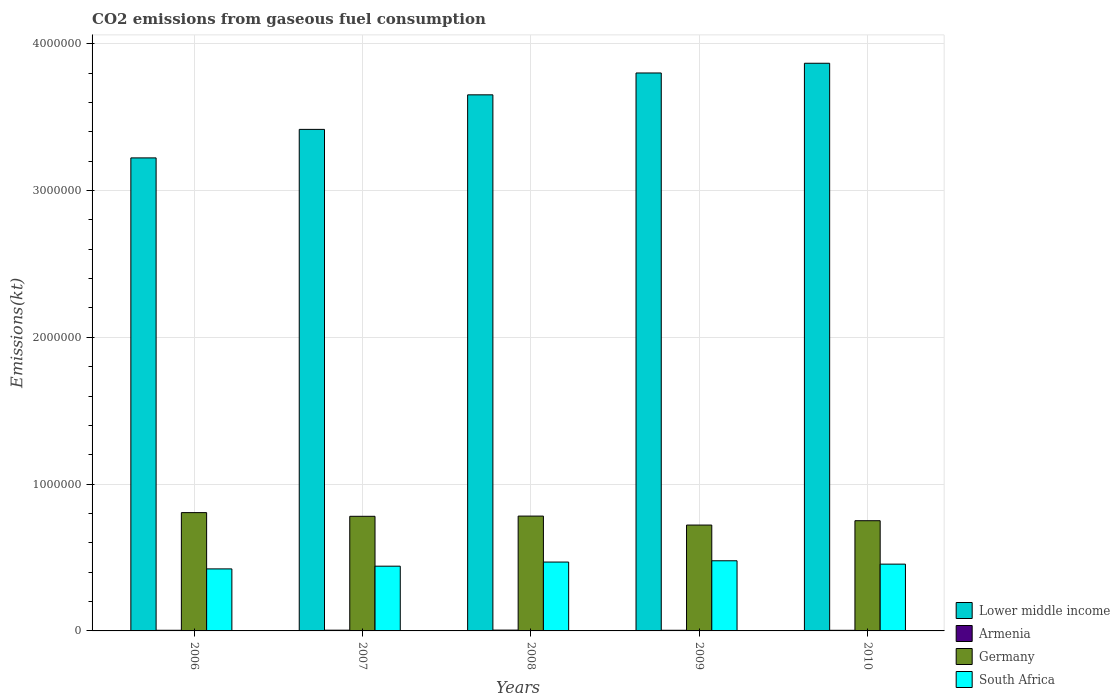How many bars are there on the 1st tick from the left?
Provide a succinct answer. 4. How many bars are there on the 4th tick from the right?
Offer a terse response. 4. What is the amount of CO2 emitted in South Africa in 2010?
Provide a succinct answer. 4.55e+05. Across all years, what is the maximum amount of CO2 emitted in South Africa?
Provide a succinct answer. 4.78e+05. Across all years, what is the minimum amount of CO2 emitted in Germany?
Offer a very short reply. 7.21e+05. In which year was the amount of CO2 emitted in Germany maximum?
Offer a very short reply. 2006. In which year was the amount of CO2 emitted in Lower middle income minimum?
Your response must be concise. 2006. What is the total amount of CO2 emitted in Germany in the graph?
Give a very brief answer. 3.84e+06. What is the difference between the amount of CO2 emitted in Germany in 2008 and that in 2009?
Provide a short and direct response. 6.11e+04. What is the difference between the amount of CO2 emitted in Lower middle income in 2008 and the amount of CO2 emitted in Germany in 2007?
Make the answer very short. 2.87e+06. What is the average amount of CO2 emitted in Lower middle income per year?
Your answer should be compact. 3.59e+06. In the year 2010, what is the difference between the amount of CO2 emitted in Germany and amount of CO2 emitted in Lower middle income?
Your answer should be very brief. -3.12e+06. What is the ratio of the amount of CO2 emitted in Armenia in 2008 to that in 2010?
Your answer should be compact. 1.32. Is the difference between the amount of CO2 emitted in Germany in 2007 and 2009 greater than the difference between the amount of CO2 emitted in Lower middle income in 2007 and 2009?
Your response must be concise. Yes. What is the difference between the highest and the second highest amount of CO2 emitted in Lower middle income?
Your answer should be compact. 6.62e+04. What is the difference between the highest and the lowest amount of CO2 emitted in South Africa?
Offer a very short reply. 5.54e+04. Is it the case that in every year, the sum of the amount of CO2 emitted in Lower middle income and amount of CO2 emitted in Germany is greater than the sum of amount of CO2 emitted in Armenia and amount of CO2 emitted in South Africa?
Your answer should be very brief. No. Is it the case that in every year, the sum of the amount of CO2 emitted in Armenia and amount of CO2 emitted in Lower middle income is greater than the amount of CO2 emitted in Germany?
Provide a succinct answer. Yes. How many bars are there?
Offer a terse response. 20. Are all the bars in the graph horizontal?
Ensure brevity in your answer.  No. What is the difference between two consecutive major ticks on the Y-axis?
Offer a very short reply. 1.00e+06. Are the values on the major ticks of Y-axis written in scientific E-notation?
Offer a very short reply. No. Does the graph contain any zero values?
Provide a succinct answer. No. Where does the legend appear in the graph?
Offer a very short reply. Bottom right. How many legend labels are there?
Your response must be concise. 4. How are the legend labels stacked?
Provide a succinct answer. Vertical. What is the title of the graph?
Your answer should be compact. CO2 emissions from gaseous fuel consumption. Does "Pacific island small states" appear as one of the legend labels in the graph?
Offer a terse response. No. What is the label or title of the X-axis?
Ensure brevity in your answer.  Years. What is the label or title of the Y-axis?
Offer a very short reply. Emissions(kt). What is the Emissions(kt) in Lower middle income in 2006?
Ensure brevity in your answer.  3.22e+06. What is the Emissions(kt) of Armenia in 2006?
Your answer should be compact. 4382.06. What is the Emissions(kt) of Germany in 2006?
Provide a short and direct response. 8.06e+05. What is the Emissions(kt) of South Africa in 2006?
Your answer should be very brief. 4.22e+05. What is the Emissions(kt) of Lower middle income in 2007?
Your answer should be compact. 3.42e+06. What is the Emissions(kt) of Armenia in 2007?
Your response must be concise. 5064.13. What is the Emissions(kt) in Germany in 2007?
Your response must be concise. 7.81e+05. What is the Emissions(kt) of South Africa in 2007?
Offer a very short reply. 4.41e+05. What is the Emissions(kt) in Lower middle income in 2008?
Offer a terse response. 3.65e+06. What is the Emissions(kt) in Armenia in 2008?
Offer a terse response. 5559.17. What is the Emissions(kt) in Germany in 2008?
Offer a terse response. 7.82e+05. What is the Emissions(kt) in South Africa in 2008?
Offer a terse response. 4.69e+05. What is the Emissions(kt) in Lower middle income in 2009?
Your answer should be compact. 3.80e+06. What is the Emissions(kt) in Armenia in 2009?
Provide a succinct answer. 4360.06. What is the Emissions(kt) of Germany in 2009?
Make the answer very short. 7.21e+05. What is the Emissions(kt) in South Africa in 2009?
Your response must be concise. 4.78e+05. What is the Emissions(kt) of Lower middle income in 2010?
Provide a short and direct response. 3.87e+06. What is the Emissions(kt) in Armenia in 2010?
Ensure brevity in your answer.  4217.05. What is the Emissions(kt) in Germany in 2010?
Your answer should be very brief. 7.51e+05. What is the Emissions(kt) in South Africa in 2010?
Provide a short and direct response. 4.55e+05. Across all years, what is the maximum Emissions(kt) of Lower middle income?
Provide a short and direct response. 3.87e+06. Across all years, what is the maximum Emissions(kt) in Armenia?
Keep it short and to the point. 5559.17. Across all years, what is the maximum Emissions(kt) of Germany?
Provide a succinct answer. 8.06e+05. Across all years, what is the maximum Emissions(kt) in South Africa?
Your answer should be compact. 4.78e+05. Across all years, what is the minimum Emissions(kt) in Lower middle income?
Provide a short and direct response. 3.22e+06. Across all years, what is the minimum Emissions(kt) of Armenia?
Offer a terse response. 4217.05. Across all years, what is the minimum Emissions(kt) in Germany?
Provide a succinct answer. 7.21e+05. Across all years, what is the minimum Emissions(kt) of South Africa?
Your answer should be compact. 4.22e+05. What is the total Emissions(kt) in Lower middle income in the graph?
Offer a terse response. 1.80e+07. What is the total Emissions(kt) of Armenia in the graph?
Make the answer very short. 2.36e+04. What is the total Emissions(kt) in Germany in the graph?
Your answer should be compact. 3.84e+06. What is the total Emissions(kt) of South Africa in the graph?
Keep it short and to the point. 2.27e+06. What is the difference between the Emissions(kt) in Lower middle income in 2006 and that in 2007?
Your answer should be compact. -1.94e+05. What is the difference between the Emissions(kt) of Armenia in 2006 and that in 2007?
Provide a succinct answer. -682.06. What is the difference between the Emissions(kt) in Germany in 2006 and that in 2007?
Keep it short and to the point. 2.52e+04. What is the difference between the Emissions(kt) in South Africa in 2006 and that in 2007?
Keep it short and to the point. -1.85e+04. What is the difference between the Emissions(kt) in Lower middle income in 2006 and that in 2008?
Make the answer very short. -4.30e+05. What is the difference between the Emissions(kt) in Armenia in 2006 and that in 2008?
Offer a terse response. -1177.11. What is the difference between the Emissions(kt) in Germany in 2006 and that in 2008?
Provide a short and direct response. 2.37e+04. What is the difference between the Emissions(kt) in South Africa in 2006 and that in 2008?
Give a very brief answer. -4.66e+04. What is the difference between the Emissions(kt) in Lower middle income in 2006 and that in 2009?
Make the answer very short. -5.78e+05. What is the difference between the Emissions(kt) in Armenia in 2006 and that in 2009?
Keep it short and to the point. 22. What is the difference between the Emissions(kt) of Germany in 2006 and that in 2009?
Offer a terse response. 8.48e+04. What is the difference between the Emissions(kt) in South Africa in 2006 and that in 2009?
Give a very brief answer. -5.54e+04. What is the difference between the Emissions(kt) of Lower middle income in 2006 and that in 2010?
Provide a succinct answer. -6.45e+05. What is the difference between the Emissions(kt) of Armenia in 2006 and that in 2010?
Ensure brevity in your answer.  165.01. What is the difference between the Emissions(kt) of Germany in 2006 and that in 2010?
Provide a succinct answer. 5.51e+04. What is the difference between the Emissions(kt) of South Africa in 2006 and that in 2010?
Keep it short and to the point. -3.25e+04. What is the difference between the Emissions(kt) of Lower middle income in 2007 and that in 2008?
Keep it short and to the point. -2.35e+05. What is the difference between the Emissions(kt) in Armenia in 2007 and that in 2008?
Ensure brevity in your answer.  -495.05. What is the difference between the Emissions(kt) of Germany in 2007 and that in 2008?
Make the answer very short. -1525.47. What is the difference between the Emissions(kt) in South Africa in 2007 and that in 2008?
Make the answer very short. -2.81e+04. What is the difference between the Emissions(kt) in Lower middle income in 2007 and that in 2009?
Ensure brevity in your answer.  -3.84e+05. What is the difference between the Emissions(kt) in Armenia in 2007 and that in 2009?
Your response must be concise. 704.06. What is the difference between the Emissions(kt) in Germany in 2007 and that in 2009?
Keep it short and to the point. 5.96e+04. What is the difference between the Emissions(kt) of South Africa in 2007 and that in 2009?
Offer a very short reply. -3.68e+04. What is the difference between the Emissions(kt) in Lower middle income in 2007 and that in 2010?
Keep it short and to the point. -4.50e+05. What is the difference between the Emissions(kt) in Armenia in 2007 and that in 2010?
Give a very brief answer. 847.08. What is the difference between the Emissions(kt) of Germany in 2007 and that in 2010?
Ensure brevity in your answer.  2.99e+04. What is the difference between the Emissions(kt) in South Africa in 2007 and that in 2010?
Make the answer very short. -1.40e+04. What is the difference between the Emissions(kt) of Lower middle income in 2008 and that in 2009?
Give a very brief answer. -1.49e+05. What is the difference between the Emissions(kt) in Armenia in 2008 and that in 2009?
Provide a short and direct response. 1199.11. What is the difference between the Emissions(kt) of Germany in 2008 and that in 2009?
Your answer should be compact. 6.11e+04. What is the difference between the Emissions(kt) in South Africa in 2008 and that in 2009?
Keep it short and to the point. -8716.46. What is the difference between the Emissions(kt) in Lower middle income in 2008 and that in 2010?
Offer a very short reply. -2.15e+05. What is the difference between the Emissions(kt) of Armenia in 2008 and that in 2010?
Offer a terse response. 1342.12. What is the difference between the Emissions(kt) in Germany in 2008 and that in 2010?
Ensure brevity in your answer.  3.15e+04. What is the difference between the Emissions(kt) in South Africa in 2008 and that in 2010?
Give a very brief answer. 1.41e+04. What is the difference between the Emissions(kt) of Lower middle income in 2009 and that in 2010?
Offer a terse response. -6.62e+04. What is the difference between the Emissions(kt) of Armenia in 2009 and that in 2010?
Offer a very short reply. 143.01. What is the difference between the Emissions(kt) of Germany in 2009 and that in 2010?
Give a very brief answer. -2.96e+04. What is the difference between the Emissions(kt) in South Africa in 2009 and that in 2010?
Ensure brevity in your answer.  2.29e+04. What is the difference between the Emissions(kt) in Lower middle income in 2006 and the Emissions(kt) in Armenia in 2007?
Your answer should be very brief. 3.22e+06. What is the difference between the Emissions(kt) in Lower middle income in 2006 and the Emissions(kt) in Germany in 2007?
Your answer should be compact. 2.44e+06. What is the difference between the Emissions(kt) of Lower middle income in 2006 and the Emissions(kt) of South Africa in 2007?
Ensure brevity in your answer.  2.78e+06. What is the difference between the Emissions(kt) in Armenia in 2006 and the Emissions(kt) in Germany in 2007?
Your answer should be very brief. -7.76e+05. What is the difference between the Emissions(kt) in Armenia in 2006 and the Emissions(kt) in South Africa in 2007?
Your response must be concise. -4.37e+05. What is the difference between the Emissions(kt) of Germany in 2006 and the Emissions(kt) of South Africa in 2007?
Offer a very short reply. 3.65e+05. What is the difference between the Emissions(kt) of Lower middle income in 2006 and the Emissions(kt) of Armenia in 2008?
Ensure brevity in your answer.  3.22e+06. What is the difference between the Emissions(kt) in Lower middle income in 2006 and the Emissions(kt) in Germany in 2008?
Make the answer very short. 2.44e+06. What is the difference between the Emissions(kt) of Lower middle income in 2006 and the Emissions(kt) of South Africa in 2008?
Your answer should be compact. 2.75e+06. What is the difference between the Emissions(kt) in Armenia in 2006 and the Emissions(kt) in Germany in 2008?
Your response must be concise. -7.78e+05. What is the difference between the Emissions(kt) in Armenia in 2006 and the Emissions(kt) in South Africa in 2008?
Provide a succinct answer. -4.65e+05. What is the difference between the Emissions(kt) in Germany in 2006 and the Emissions(kt) in South Africa in 2008?
Make the answer very short. 3.37e+05. What is the difference between the Emissions(kt) of Lower middle income in 2006 and the Emissions(kt) of Armenia in 2009?
Your answer should be very brief. 3.22e+06. What is the difference between the Emissions(kt) of Lower middle income in 2006 and the Emissions(kt) of Germany in 2009?
Make the answer very short. 2.50e+06. What is the difference between the Emissions(kt) of Lower middle income in 2006 and the Emissions(kt) of South Africa in 2009?
Your answer should be very brief. 2.74e+06. What is the difference between the Emissions(kt) of Armenia in 2006 and the Emissions(kt) of Germany in 2009?
Provide a succinct answer. -7.17e+05. What is the difference between the Emissions(kt) of Armenia in 2006 and the Emissions(kt) of South Africa in 2009?
Provide a short and direct response. -4.73e+05. What is the difference between the Emissions(kt) in Germany in 2006 and the Emissions(kt) in South Africa in 2009?
Provide a succinct answer. 3.28e+05. What is the difference between the Emissions(kt) of Lower middle income in 2006 and the Emissions(kt) of Armenia in 2010?
Provide a succinct answer. 3.22e+06. What is the difference between the Emissions(kt) in Lower middle income in 2006 and the Emissions(kt) in Germany in 2010?
Provide a short and direct response. 2.47e+06. What is the difference between the Emissions(kt) in Lower middle income in 2006 and the Emissions(kt) in South Africa in 2010?
Your response must be concise. 2.77e+06. What is the difference between the Emissions(kt) in Armenia in 2006 and the Emissions(kt) in Germany in 2010?
Offer a terse response. -7.46e+05. What is the difference between the Emissions(kt) of Armenia in 2006 and the Emissions(kt) of South Africa in 2010?
Your response must be concise. -4.51e+05. What is the difference between the Emissions(kt) in Germany in 2006 and the Emissions(kt) in South Africa in 2010?
Offer a terse response. 3.51e+05. What is the difference between the Emissions(kt) of Lower middle income in 2007 and the Emissions(kt) of Armenia in 2008?
Your answer should be compact. 3.41e+06. What is the difference between the Emissions(kt) of Lower middle income in 2007 and the Emissions(kt) of Germany in 2008?
Give a very brief answer. 2.63e+06. What is the difference between the Emissions(kt) in Lower middle income in 2007 and the Emissions(kt) in South Africa in 2008?
Your answer should be compact. 2.95e+06. What is the difference between the Emissions(kt) of Armenia in 2007 and the Emissions(kt) of Germany in 2008?
Offer a terse response. -7.77e+05. What is the difference between the Emissions(kt) of Armenia in 2007 and the Emissions(kt) of South Africa in 2008?
Give a very brief answer. -4.64e+05. What is the difference between the Emissions(kt) in Germany in 2007 and the Emissions(kt) in South Africa in 2008?
Offer a terse response. 3.12e+05. What is the difference between the Emissions(kt) in Lower middle income in 2007 and the Emissions(kt) in Armenia in 2009?
Provide a succinct answer. 3.41e+06. What is the difference between the Emissions(kt) of Lower middle income in 2007 and the Emissions(kt) of Germany in 2009?
Ensure brevity in your answer.  2.70e+06. What is the difference between the Emissions(kt) of Lower middle income in 2007 and the Emissions(kt) of South Africa in 2009?
Your response must be concise. 2.94e+06. What is the difference between the Emissions(kt) of Armenia in 2007 and the Emissions(kt) of Germany in 2009?
Offer a very short reply. -7.16e+05. What is the difference between the Emissions(kt) of Armenia in 2007 and the Emissions(kt) of South Africa in 2009?
Offer a terse response. -4.73e+05. What is the difference between the Emissions(kt) in Germany in 2007 and the Emissions(kt) in South Africa in 2009?
Provide a succinct answer. 3.03e+05. What is the difference between the Emissions(kt) of Lower middle income in 2007 and the Emissions(kt) of Armenia in 2010?
Offer a terse response. 3.41e+06. What is the difference between the Emissions(kt) in Lower middle income in 2007 and the Emissions(kt) in Germany in 2010?
Keep it short and to the point. 2.67e+06. What is the difference between the Emissions(kt) of Lower middle income in 2007 and the Emissions(kt) of South Africa in 2010?
Give a very brief answer. 2.96e+06. What is the difference between the Emissions(kt) of Armenia in 2007 and the Emissions(kt) of Germany in 2010?
Provide a short and direct response. -7.46e+05. What is the difference between the Emissions(kt) of Armenia in 2007 and the Emissions(kt) of South Africa in 2010?
Provide a succinct answer. -4.50e+05. What is the difference between the Emissions(kt) of Germany in 2007 and the Emissions(kt) of South Africa in 2010?
Offer a very short reply. 3.26e+05. What is the difference between the Emissions(kt) of Lower middle income in 2008 and the Emissions(kt) of Armenia in 2009?
Offer a terse response. 3.65e+06. What is the difference between the Emissions(kt) in Lower middle income in 2008 and the Emissions(kt) in Germany in 2009?
Give a very brief answer. 2.93e+06. What is the difference between the Emissions(kt) of Lower middle income in 2008 and the Emissions(kt) of South Africa in 2009?
Your answer should be compact. 3.17e+06. What is the difference between the Emissions(kt) of Armenia in 2008 and the Emissions(kt) of Germany in 2009?
Ensure brevity in your answer.  -7.16e+05. What is the difference between the Emissions(kt) of Armenia in 2008 and the Emissions(kt) of South Africa in 2009?
Offer a very short reply. -4.72e+05. What is the difference between the Emissions(kt) in Germany in 2008 and the Emissions(kt) in South Africa in 2009?
Keep it short and to the point. 3.04e+05. What is the difference between the Emissions(kt) in Lower middle income in 2008 and the Emissions(kt) in Armenia in 2010?
Give a very brief answer. 3.65e+06. What is the difference between the Emissions(kt) in Lower middle income in 2008 and the Emissions(kt) in Germany in 2010?
Keep it short and to the point. 2.90e+06. What is the difference between the Emissions(kt) in Lower middle income in 2008 and the Emissions(kt) in South Africa in 2010?
Offer a very short reply. 3.20e+06. What is the difference between the Emissions(kt) of Armenia in 2008 and the Emissions(kt) of Germany in 2010?
Your answer should be very brief. -7.45e+05. What is the difference between the Emissions(kt) of Armenia in 2008 and the Emissions(kt) of South Africa in 2010?
Provide a short and direct response. -4.49e+05. What is the difference between the Emissions(kt) of Germany in 2008 and the Emissions(kt) of South Africa in 2010?
Make the answer very short. 3.27e+05. What is the difference between the Emissions(kt) in Lower middle income in 2009 and the Emissions(kt) in Armenia in 2010?
Ensure brevity in your answer.  3.80e+06. What is the difference between the Emissions(kt) of Lower middle income in 2009 and the Emissions(kt) of Germany in 2010?
Provide a short and direct response. 3.05e+06. What is the difference between the Emissions(kt) of Lower middle income in 2009 and the Emissions(kt) of South Africa in 2010?
Provide a short and direct response. 3.35e+06. What is the difference between the Emissions(kt) of Armenia in 2009 and the Emissions(kt) of Germany in 2010?
Offer a very short reply. -7.46e+05. What is the difference between the Emissions(kt) in Armenia in 2009 and the Emissions(kt) in South Africa in 2010?
Your answer should be compact. -4.51e+05. What is the difference between the Emissions(kt) in Germany in 2009 and the Emissions(kt) in South Africa in 2010?
Your response must be concise. 2.66e+05. What is the average Emissions(kt) of Lower middle income per year?
Provide a succinct answer. 3.59e+06. What is the average Emissions(kt) in Armenia per year?
Offer a terse response. 4716.5. What is the average Emissions(kt) of Germany per year?
Provide a succinct answer. 7.68e+05. What is the average Emissions(kt) in South Africa per year?
Ensure brevity in your answer.  4.53e+05. In the year 2006, what is the difference between the Emissions(kt) in Lower middle income and Emissions(kt) in Armenia?
Your response must be concise. 3.22e+06. In the year 2006, what is the difference between the Emissions(kt) of Lower middle income and Emissions(kt) of Germany?
Provide a short and direct response. 2.42e+06. In the year 2006, what is the difference between the Emissions(kt) in Lower middle income and Emissions(kt) in South Africa?
Provide a short and direct response. 2.80e+06. In the year 2006, what is the difference between the Emissions(kt) of Armenia and Emissions(kt) of Germany?
Your answer should be compact. -8.01e+05. In the year 2006, what is the difference between the Emissions(kt) of Armenia and Emissions(kt) of South Africa?
Keep it short and to the point. -4.18e+05. In the year 2006, what is the difference between the Emissions(kt) of Germany and Emissions(kt) of South Africa?
Your answer should be very brief. 3.83e+05. In the year 2007, what is the difference between the Emissions(kt) in Lower middle income and Emissions(kt) in Armenia?
Offer a terse response. 3.41e+06. In the year 2007, what is the difference between the Emissions(kt) in Lower middle income and Emissions(kt) in Germany?
Your answer should be compact. 2.64e+06. In the year 2007, what is the difference between the Emissions(kt) in Lower middle income and Emissions(kt) in South Africa?
Provide a succinct answer. 2.98e+06. In the year 2007, what is the difference between the Emissions(kt) of Armenia and Emissions(kt) of Germany?
Keep it short and to the point. -7.76e+05. In the year 2007, what is the difference between the Emissions(kt) in Armenia and Emissions(kt) in South Africa?
Ensure brevity in your answer.  -4.36e+05. In the year 2007, what is the difference between the Emissions(kt) of Germany and Emissions(kt) of South Africa?
Give a very brief answer. 3.40e+05. In the year 2008, what is the difference between the Emissions(kt) in Lower middle income and Emissions(kt) in Armenia?
Offer a very short reply. 3.65e+06. In the year 2008, what is the difference between the Emissions(kt) in Lower middle income and Emissions(kt) in Germany?
Give a very brief answer. 2.87e+06. In the year 2008, what is the difference between the Emissions(kt) of Lower middle income and Emissions(kt) of South Africa?
Keep it short and to the point. 3.18e+06. In the year 2008, what is the difference between the Emissions(kt) of Armenia and Emissions(kt) of Germany?
Give a very brief answer. -7.77e+05. In the year 2008, what is the difference between the Emissions(kt) in Armenia and Emissions(kt) in South Africa?
Your answer should be very brief. -4.64e+05. In the year 2008, what is the difference between the Emissions(kt) of Germany and Emissions(kt) of South Africa?
Your response must be concise. 3.13e+05. In the year 2009, what is the difference between the Emissions(kt) in Lower middle income and Emissions(kt) in Armenia?
Your response must be concise. 3.80e+06. In the year 2009, what is the difference between the Emissions(kt) of Lower middle income and Emissions(kt) of Germany?
Make the answer very short. 3.08e+06. In the year 2009, what is the difference between the Emissions(kt) of Lower middle income and Emissions(kt) of South Africa?
Provide a short and direct response. 3.32e+06. In the year 2009, what is the difference between the Emissions(kt) of Armenia and Emissions(kt) of Germany?
Make the answer very short. -7.17e+05. In the year 2009, what is the difference between the Emissions(kt) of Armenia and Emissions(kt) of South Africa?
Ensure brevity in your answer.  -4.73e+05. In the year 2009, what is the difference between the Emissions(kt) in Germany and Emissions(kt) in South Africa?
Your answer should be very brief. 2.43e+05. In the year 2010, what is the difference between the Emissions(kt) in Lower middle income and Emissions(kt) in Armenia?
Provide a succinct answer. 3.86e+06. In the year 2010, what is the difference between the Emissions(kt) of Lower middle income and Emissions(kt) of Germany?
Keep it short and to the point. 3.12e+06. In the year 2010, what is the difference between the Emissions(kt) in Lower middle income and Emissions(kt) in South Africa?
Provide a succinct answer. 3.41e+06. In the year 2010, what is the difference between the Emissions(kt) in Armenia and Emissions(kt) in Germany?
Keep it short and to the point. -7.46e+05. In the year 2010, what is the difference between the Emissions(kt) of Armenia and Emissions(kt) of South Africa?
Provide a succinct answer. -4.51e+05. In the year 2010, what is the difference between the Emissions(kt) in Germany and Emissions(kt) in South Africa?
Offer a very short reply. 2.96e+05. What is the ratio of the Emissions(kt) in Lower middle income in 2006 to that in 2007?
Make the answer very short. 0.94. What is the ratio of the Emissions(kt) in Armenia in 2006 to that in 2007?
Your answer should be very brief. 0.87. What is the ratio of the Emissions(kt) in Germany in 2006 to that in 2007?
Ensure brevity in your answer.  1.03. What is the ratio of the Emissions(kt) in South Africa in 2006 to that in 2007?
Your answer should be compact. 0.96. What is the ratio of the Emissions(kt) of Lower middle income in 2006 to that in 2008?
Keep it short and to the point. 0.88. What is the ratio of the Emissions(kt) of Armenia in 2006 to that in 2008?
Give a very brief answer. 0.79. What is the ratio of the Emissions(kt) of Germany in 2006 to that in 2008?
Provide a succinct answer. 1.03. What is the ratio of the Emissions(kt) of South Africa in 2006 to that in 2008?
Offer a terse response. 0.9. What is the ratio of the Emissions(kt) in Lower middle income in 2006 to that in 2009?
Your answer should be compact. 0.85. What is the ratio of the Emissions(kt) in Armenia in 2006 to that in 2009?
Provide a short and direct response. 1. What is the ratio of the Emissions(kt) in Germany in 2006 to that in 2009?
Ensure brevity in your answer.  1.12. What is the ratio of the Emissions(kt) of South Africa in 2006 to that in 2009?
Offer a terse response. 0.88. What is the ratio of the Emissions(kt) in Armenia in 2006 to that in 2010?
Offer a terse response. 1.04. What is the ratio of the Emissions(kt) in Germany in 2006 to that in 2010?
Provide a succinct answer. 1.07. What is the ratio of the Emissions(kt) in Lower middle income in 2007 to that in 2008?
Offer a terse response. 0.94. What is the ratio of the Emissions(kt) of Armenia in 2007 to that in 2008?
Offer a very short reply. 0.91. What is the ratio of the Emissions(kt) in South Africa in 2007 to that in 2008?
Provide a succinct answer. 0.94. What is the ratio of the Emissions(kt) in Lower middle income in 2007 to that in 2009?
Provide a succinct answer. 0.9. What is the ratio of the Emissions(kt) of Armenia in 2007 to that in 2009?
Offer a very short reply. 1.16. What is the ratio of the Emissions(kt) in Germany in 2007 to that in 2009?
Make the answer very short. 1.08. What is the ratio of the Emissions(kt) of South Africa in 2007 to that in 2009?
Offer a terse response. 0.92. What is the ratio of the Emissions(kt) in Lower middle income in 2007 to that in 2010?
Keep it short and to the point. 0.88. What is the ratio of the Emissions(kt) in Armenia in 2007 to that in 2010?
Your response must be concise. 1.2. What is the ratio of the Emissions(kt) in Germany in 2007 to that in 2010?
Provide a succinct answer. 1.04. What is the ratio of the Emissions(kt) of South Africa in 2007 to that in 2010?
Provide a succinct answer. 0.97. What is the ratio of the Emissions(kt) of Lower middle income in 2008 to that in 2009?
Your response must be concise. 0.96. What is the ratio of the Emissions(kt) in Armenia in 2008 to that in 2009?
Keep it short and to the point. 1.27. What is the ratio of the Emissions(kt) in Germany in 2008 to that in 2009?
Make the answer very short. 1.08. What is the ratio of the Emissions(kt) of South Africa in 2008 to that in 2009?
Offer a very short reply. 0.98. What is the ratio of the Emissions(kt) of Armenia in 2008 to that in 2010?
Make the answer very short. 1.32. What is the ratio of the Emissions(kt) in Germany in 2008 to that in 2010?
Your answer should be compact. 1.04. What is the ratio of the Emissions(kt) of South Africa in 2008 to that in 2010?
Your response must be concise. 1.03. What is the ratio of the Emissions(kt) in Lower middle income in 2009 to that in 2010?
Offer a terse response. 0.98. What is the ratio of the Emissions(kt) in Armenia in 2009 to that in 2010?
Give a very brief answer. 1.03. What is the ratio of the Emissions(kt) in Germany in 2009 to that in 2010?
Your response must be concise. 0.96. What is the ratio of the Emissions(kt) of South Africa in 2009 to that in 2010?
Your response must be concise. 1.05. What is the difference between the highest and the second highest Emissions(kt) of Lower middle income?
Provide a short and direct response. 6.62e+04. What is the difference between the highest and the second highest Emissions(kt) in Armenia?
Keep it short and to the point. 495.05. What is the difference between the highest and the second highest Emissions(kt) in Germany?
Offer a very short reply. 2.37e+04. What is the difference between the highest and the second highest Emissions(kt) of South Africa?
Ensure brevity in your answer.  8716.46. What is the difference between the highest and the lowest Emissions(kt) in Lower middle income?
Give a very brief answer. 6.45e+05. What is the difference between the highest and the lowest Emissions(kt) in Armenia?
Your answer should be very brief. 1342.12. What is the difference between the highest and the lowest Emissions(kt) of Germany?
Offer a terse response. 8.48e+04. What is the difference between the highest and the lowest Emissions(kt) of South Africa?
Your response must be concise. 5.54e+04. 